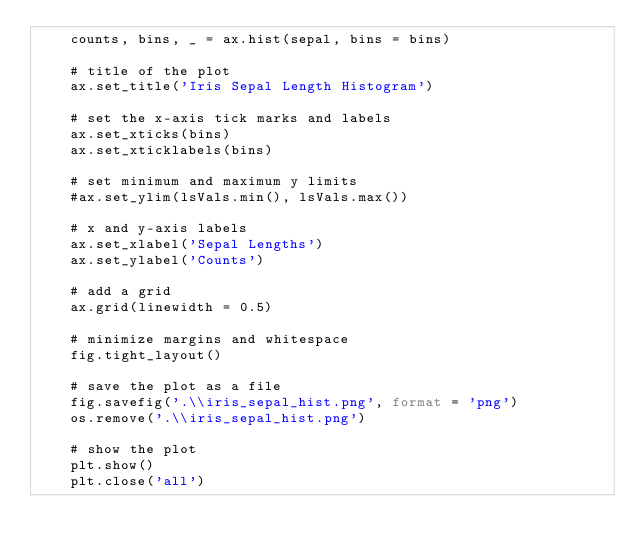<code> <loc_0><loc_0><loc_500><loc_500><_Python_>    counts, bins, _ = ax.hist(sepal, bins = bins)

    # title of the plot
    ax.set_title('Iris Sepal Length Histogram')

    # set the x-axis tick marks and labels
    ax.set_xticks(bins)
    ax.set_xticklabels(bins)

    # set minimum and maximum y limits
    #ax.set_ylim(lsVals.min(), lsVals.max())

    # x and y-axis labels
    ax.set_xlabel('Sepal Lengths')
    ax.set_ylabel('Counts')

    # add a grid
    ax.grid(linewidth = 0.5)

    # minimize margins and whitespace
    fig.tight_layout()

    # save the plot as a file
    fig.savefig('.\\iris_sepal_hist.png', format = 'png')
    os.remove('.\\iris_sepal_hist.png')

    # show the plot
    plt.show()
    plt.close('all')</code> 